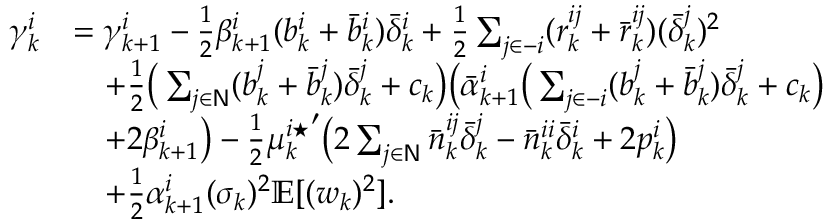Convert formula to latex. <formula><loc_0><loc_0><loc_500><loc_500>\begin{array} { r l } { \gamma _ { k } ^ { i } } & { = \gamma _ { k + 1 } ^ { i } - \frac { 1 } { 2 } \beta _ { k + 1 } ^ { i } ( b _ { k } ^ { i } + \bar { b } _ { k } ^ { i } ) \bar { \delta } _ { k } ^ { i } + \frac { 1 } { 2 } \sum _ { j \in - i } ( r _ { k } ^ { i j } + \bar { r } _ { k } ^ { i j } ) ( \bar { \delta } _ { k } ^ { j } ) ^ { 2 } } \\ & { \quad + \frac { 1 } { 2 } \left ( \sum _ { j \in N } ( b _ { k } ^ { j } + \bar { b } _ { k } ^ { j } ) \bar { \delta } _ { k } ^ { j } + c _ { k } \right ) \left ( \bar { \alpha } _ { k + 1 } ^ { i } \left ( \sum _ { j \in - i } ( b _ { k } ^ { j } + \bar { b } _ { k } ^ { j } ) \bar { \delta } _ { k } ^ { j } + c _ { k } \right ) } \\ & { \quad + 2 \beta _ { k + 1 } ^ { i } \right ) - \frac { 1 } { 2 } { \mu _ { k } ^ { i ^ { * } } } ^ { \prime } \left ( 2 \sum _ { j \in N } \bar { n } _ { k } ^ { i j } \bar { \delta } _ { k } ^ { j } - \bar { n } _ { k } ^ { i i } \bar { \delta } _ { k } ^ { i } + 2 p _ { k } ^ { i } \right ) } \\ & { \quad + \frac { 1 } { 2 } \alpha _ { k + 1 } ^ { i } ( \sigma _ { k } ) ^ { 2 } \mathbb { E } [ ( w _ { k } ) ^ { 2 } ] . } \end{array}</formula> 